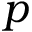<formula> <loc_0><loc_0><loc_500><loc_500>p</formula> 